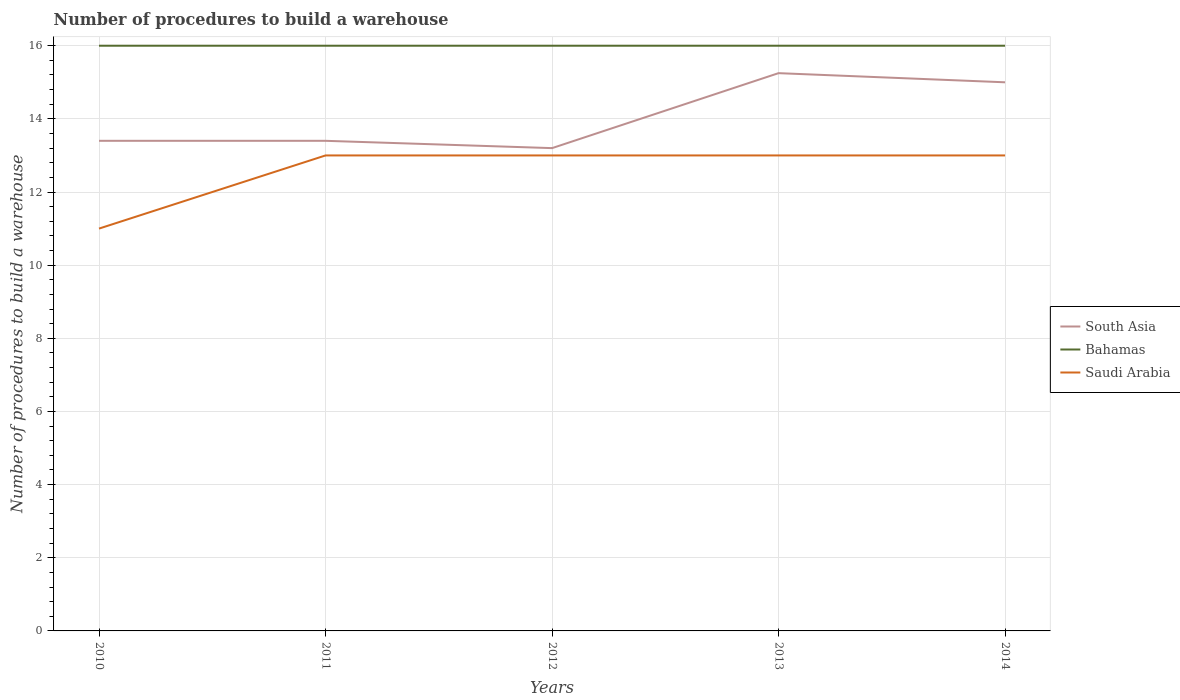Does the line corresponding to South Asia intersect with the line corresponding to Bahamas?
Your response must be concise. No. Is the number of lines equal to the number of legend labels?
Offer a very short reply. Yes. Across all years, what is the maximum number of procedures to build a warehouse in in South Asia?
Offer a very short reply. 13.2. In which year was the number of procedures to build a warehouse in in Saudi Arabia maximum?
Keep it short and to the point. 2010. What is the total number of procedures to build a warehouse in in South Asia in the graph?
Your answer should be compact. -1.8. What is the difference between the highest and the second highest number of procedures to build a warehouse in in Saudi Arabia?
Your response must be concise. 2. How many lines are there?
Offer a terse response. 3. How many years are there in the graph?
Provide a short and direct response. 5. What is the difference between two consecutive major ticks on the Y-axis?
Provide a succinct answer. 2. Are the values on the major ticks of Y-axis written in scientific E-notation?
Keep it short and to the point. No. Does the graph contain any zero values?
Keep it short and to the point. No. Where does the legend appear in the graph?
Offer a terse response. Center right. How are the legend labels stacked?
Make the answer very short. Vertical. What is the title of the graph?
Your response must be concise. Number of procedures to build a warehouse. What is the label or title of the Y-axis?
Provide a succinct answer. Number of procedures to build a warehouse. What is the Number of procedures to build a warehouse in South Asia in 2010?
Offer a terse response. 13.4. What is the Number of procedures to build a warehouse in Saudi Arabia in 2011?
Provide a short and direct response. 13. What is the Number of procedures to build a warehouse in South Asia in 2012?
Ensure brevity in your answer.  13.2. What is the Number of procedures to build a warehouse in Saudi Arabia in 2012?
Offer a very short reply. 13. What is the Number of procedures to build a warehouse of South Asia in 2013?
Your answer should be compact. 15.25. What is the Number of procedures to build a warehouse of Bahamas in 2013?
Offer a terse response. 16. What is the Number of procedures to build a warehouse in Saudi Arabia in 2013?
Keep it short and to the point. 13. Across all years, what is the maximum Number of procedures to build a warehouse in South Asia?
Provide a succinct answer. 15.25. Across all years, what is the maximum Number of procedures to build a warehouse of Bahamas?
Your answer should be very brief. 16. Across all years, what is the maximum Number of procedures to build a warehouse of Saudi Arabia?
Ensure brevity in your answer.  13. What is the total Number of procedures to build a warehouse of South Asia in the graph?
Offer a very short reply. 70.25. What is the total Number of procedures to build a warehouse in Saudi Arabia in the graph?
Ensure brevity in your answer.  63. What is the difference between the Number of procedures to build a warehouse in South Asia in 2010 and that in 2011?
Your response must be concise. 0. What is the difference between the Number of procedures to build a warehouse in Bahamas in 2010 and that in 2011?
Your response must be concise. 0. What is the difference between the Number of procedures to build a warehouse in Saudi Arabia in 2010 and that in 2011?
Make the answer very short. -2. What is the difference between the Number of procedures to build a warehouse in South Asia in 2010 and that in 2013?
Offer a very short reply. -1.85. What is the difference between the Number of procedures to build a warehouse of Bahamas in 2010 and that in 2013?
Give a very brief answer. 0. What is the difference between the Number of procedures to build a warehouse of Bahamas in 2010 and that in 2014?
Make the answer very short. 0. What is the difference between the Number of procedures to build a warehouse of South Asia in 2011 and that in 2013?
Offer a very short reply. -1.85. What is the difference between the Number of procedures to build a warehouse in Saudi Arabia in 2011 and that in 2013?
Ensure brevity in your answer.  0. What is the difference between the Number of procedures to build a warehouse in Saudi Arabia in 2011 and that in 2014?
Provide a succinct answer. 0. What is the difference between the Number of procedures to build a warehouse of South Asia in 2012 and that in 2013?
Give a very brief answer. -2.05. What is the difference between the Number of procedures to build a warehouse of South Asia in 2012 and that in 2014?
Your answer should be compact. -1.8. What is the difference between the Number of procedures to build a warehouse of Bahamas in 2012 and that in 2014?
Your response must be concise. 0. What is the difference between the Number of procedures to build a warehouse of South Asia in 2010 and the Number of procedures to build a warehouse of Saudi Arabia in 2011?
Keep it short and to the point. 0.4. What is the difference between the Number of procedures to build a warehouse in South Asia in 2010 and the Number of procedures to build a warehouse in Bahamas in 2012?
Keep it short and to the point. -2.6. What is the difference between the Number of procedures to build a warehouse in South Asia in 2010 and the Number of procedures to build a warehouse in Saudi Arabia in 2013?
Offer a very short reply. 0.4. What is the difference between the Number of procedures to build a warehouse of Bahamas in 2010 and the Number of procedures to build a warehouse of Saudi Arabia in 2013?
Give a very brief answer. 3. What is the difference between the Number of procedures to build a warehouse of South Asia in 2010 and the Number of procedures to build a warehouse of Bahamas in 2014?
Provide a short and direct response. -2.6. What is the difference between the Number of procedures to build a warehouse in South Asia in 2010 and the Number of procedures to build a warehouse in Saudi Arabia in 2014?
Offer a very short reply. 0.4. What is the difference between the Number of procedures to build a warehouse of Bahamas in 2010 and the Number of procedures to build a warehouse of Saudi Arabia in 2014?
Your answer should be very brief. 3. What is the difference between the Number of procedures to build a warehouse in South Asia in 2011 and the Number of procedures to build a warehouse in Bahamas in 2012?
Offer a very short reply. -2.6. What is the difference between the Number of procedures to build a warehouse in South Asia in 2011 and the Number of procedures to build a warehouse in Bahamas in 2013?
Offer a very short reply. -2.6. What is the difference between the Number of procedures to build a warehouse of South Asia in 2011 and the Number of procedures to build a warehouse of Saudi Arabia in 2013?
Your answer should be very brief. 0.4. What is the difference between the Number of procedures to build a warehouse of South Asia in 2011 and the Number of procedures to build a warehouse of Bahamas in 2014?
Your response must be concise. -2.6. What is the difference between the Number of procedures to build a warehouse of South Asia in 2011 and the Number of procedures to build a warehouse of Saudi Arabia in 2014?
Your answer should be compact. 0.4. What is the difference between the Number of procedures to build a warehouse of Bahamas in 2011 and the Number of procedures to build a warehouse of Saudi Arabia in 2014?
Your answer should be very brief. 3. What is the difference between the Number of procedures to build a warehouse of South Asia in 2012 and the Number of procedures to build a warehouse of Saudi Arabia in 2013?
Offer a very short reply. 0.2. What is the difference between the Number of procedures to build a warehouse of Bahamas in 2012 and the Number of procedures to build a warehouse of Saudi Arabia in 2013?
Offer a terse response. 3. What is the difference between the Number of procedures to build a warehouse of South Asia in 2013 and the Number of procedures to build a warehouse of Bahamas in 2014?
Ensure brevity in your answer.  -0.75. What is the difference between the Number of procedures to build a warehouse in South Asia in 2013 and the Number of procedures to build a warehouse in Saudi Arabia in 2014?
Your response must be concise. 2.25. What is the difference between the Number of procedures to build a warehouse of Bahamas in 2013 and the Number of procedures to build a warehouse of Saudi Arabia in 2014?
Keep it short and to the point. 3. What is the average Number of procedures to build a warehouse in South Asia per year?
Provide a short and direct response. 14.05. What is the average Number of procedures to build a warehouse in Bahamas per year?
Give a very brief answer. 16. In the year 2010, what is the difference between the Number of procedures to build a warehouse of Bahamas and Number of procedures to build a warehouse of Saudi Arabia?
Offer a terse response. 5. In the year 2011, what is the difference between the Number of procedures to build a warehouse of South Asia and Number of procedures to build a warehouse of Saudi Arabia?
Give a very brief answer. 0.4. In the year 2011, what is the difference between the Number of procedures to build a warehouse of Bahamas and Number of procedures to build a warehouse of Saudi Arabia?
Your answer should be compact. 3. In the year 2012, what is the difference between the Number of procedures to build a warehouse of South Asia and Number of procedures to build a warehouse of Saudi Arabia?
Provide a short and direct response. 0.2. In the year 2013, what is the difference between the Number of procedures to build a warehouse of South Asia and Number of procedures to build a warehouse of Bahamas?
Your answer should be very brief. -0.75. In the year 2013, what is the difference between the Number of procedures to build a warehouse of South Asia and Number of procedures to build a warehouse of Saudi Arabia?
Provide a short and direct response. 2.25. In the year 2013, what is the difference between the Number of procedures to build a warehouse in Bahamas and Number of procedures to build a warehouse in Saudi Arabia?
Your answer should be compact. 3. In the year 2014, what is the difference between the Number of procedures to build a warehouse of South Asia and Number of procedures to build a warehouse of Bahamas?
Offer a very short reply. -1. What is the ratio of the Number of procedures to build a warehouse of Bahamas in 2010 to that in 2011?
Your answer should be very brief. 1. What is the ratio of the Number of procedures to build a warehouse in Saudi Arabia in 2010 to that in 2011?
Your response must be concise. 0.85. What is the ratio of the Number of procedures to build a warehouse of South Asia in 2010 to that in 2012?
Your answer should be compact. 1.02. What is the ratio of the Number of procedures to build a warehouse of Bahamas in 2010 to that in 2012?
Make the answer very short. 1. What is the ratio of the Number of procedures to build a warehouse of Saudi Arabia in 2010 to that in 2012?
Offer a very short reply. 0.85. What is the ratio of the Number of procedures to build a warehouse in South Asia in 2010 to that in 2013?
Your answer should be very brief. 0.88. What is the ratio of the Number of procedures to build a warehouse of Bahamas in 2010 to that in 2013?
Offer a terse response. 1. What is the ratio of the Number of procedures to build a warehouse in Saudi Arabia in 2010 to that in 2013?
Provide a succinct answer. 0.85. What is the ratio of the Number of procedures to build a warehouse of South Asia in 2010 to that in 2014?
Make the answer very short. 0.89. What is the ratio of the Number of procedures to build a warehouse of Saudi Arabia in 2010 to that in 2014?
Ensure brevity in your answer.  0.85. What is the ratio of the Number of procedures to build a warehouse of South Asia in 2011 to that in 2012?
Make the answer very short. 1.02. What is the ratio of the Number of procedures to build a warehouse in Saudi Arabia in 2011 to that in 2012?
Make the answer very short. 1. What is the ratio of the Number of procedures to build a warehouse of South Asia in 2011 to that in 2013?
Offer a very short reply. 0.88. What is the ratio of the Number of procedures to build a warehouse in Bahamas in 2011 to that in 2013?
Give a very brief answer. 1. What is the ratio of the Number of procedures to build a warehouse of Saudi Arabia in 2011 to that in 2013?
Give a very brief answer. 1. What is the ratio of the Number of procedures to build a warehouse of South Asia in 2011 to that in 2014?
Offer a very short reply. 0.89. What is the ratio of the Number of procedures to build a warehouse of South Asia in 2012 to that in 2013?
Make the answer very short. 0.87. What is the ratio of the Number of procedures to build a warehouse of South Asia in 2012 to that in 2014?
Make the answer very short. 0.88. What is the ratio of the Number of procedures to build a warehouse of Bahamas in 2012 to that in 2014?
Keep it short and to the point. 1. What is the ratio of the Number of procedures to build a warehouse in South Asia in 2013 to that in 2014?
Give a very brief answer. 1.02. What is the ratio of the Number of procedures to build a warehouse of Bahamas in 2013 to that in 2014?
Your answer should be compact. 1. What is the difference between the highest and the second highest Number of procedures to build a warehouse of Bahamas?
Keep it short and to the point. 0. What is the difference between the highest and the second highest Number of procedures to build a warehouse in Saudi Arabia?
Your response must be concise. 0. What is the difference between the highest and the lowest Number of procedures to build a warehouse in South Asia?
Make the answer very short. 2.05. What is the difference between the highest and the lowest Number of procedures to build a warehouse of Saudi Arabia?
Offer a terse response. 2. 